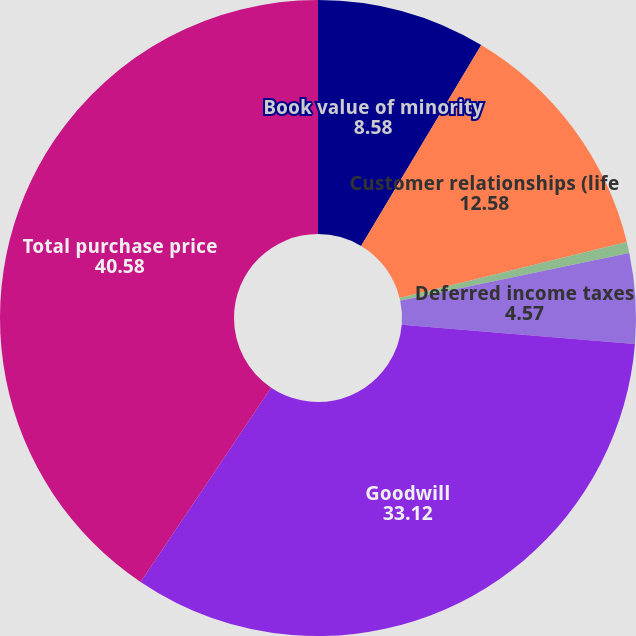<chart> <loc_0><loc_0><loc_500><loc_500><pie_chart><fcel>Book value of minority<fcel>Customer relationships (life<fcel>Other identifiable intangible<fcel>Deferred income taxes<fcel>Goodwill<fcel>Total purchase price<nl><fcel>8.58%<fcel>12.58%<fcel>0.57%<fcel>4.57%<fcel>33.12%<fcel>40.58%<nl></chart> 